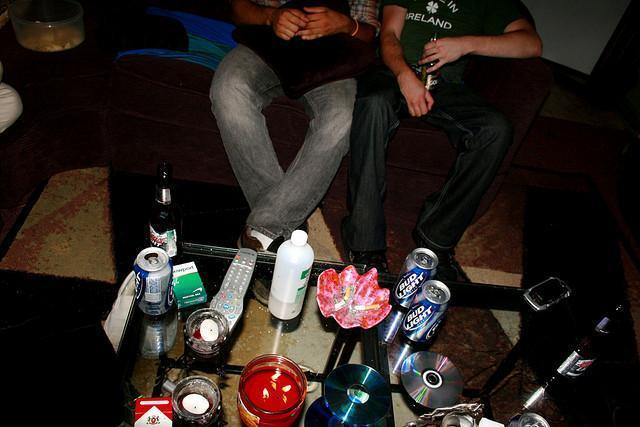How many bottles are visible?
Give a very brief answer. 3. How many people can be seen?
Give a very brief answer. 2. 